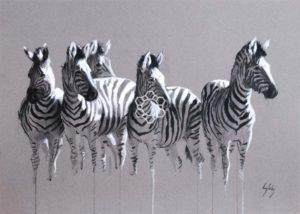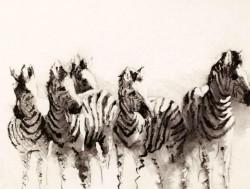The first image is the image on the left, the second image is the image on the right. Given the left and right images, does the statement "There is only one zebra in the right image." hold true? Answer yes or no. No. 